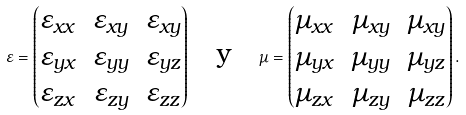Convert formula to latex. <formula><loc_0><loc_0><loc_500><loc_500>\varepsilon = \begin{pmatrix} \varepsilon _ { x x } & \varepsilon _ { x y } & \varepsilon _ { x y } \\ \varepsilon _ { y x } & \varepsilon _ { y y } & \varepsilon _ { y z } \\ \varepsilon _ { z x } & \varepsilon _ { z y } & \varepsilon _ { z z } \\ \end{pmatrix} \quad \text {y} \quad \mu = \begin{pmatrix} \mu _ { x x } & \mu _ { x y } & \mu _ { x y } \\ \mu _ { y x } & \mu _ { y y } & \mu _ { y z } \\ \mu _ { z x } & \mu _ { z y } & \mu _ { z z } \\ \end{pmatrix} .</formula> 